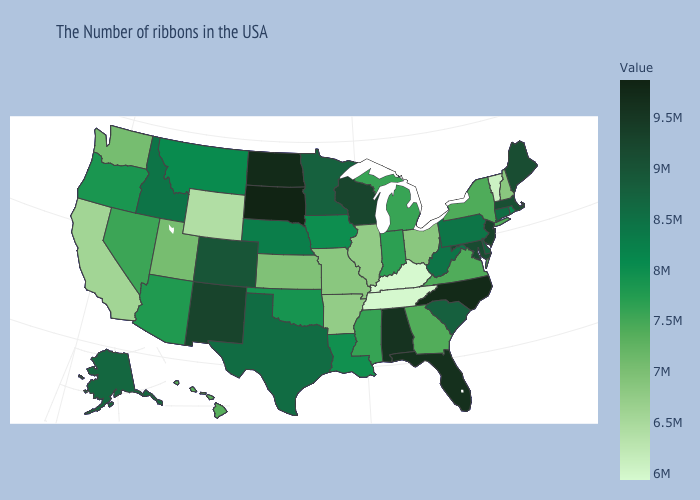Is the legend a continuous bar?
Keep it brief. Yes. Which states hav the highest value in the MidWest?
Short answer required. South Dakota. Among the states that border Alabama , which have the highest value?
Short answer required. Florida. Which states hav the highest value in the South?
Quick response, please. North Carolina. Among the states that border Indiana , does Ohio have the lowest value?
Concise answer only. No. Does Wyoming have a higher value than Tennessee?
Be succinct. Yes. 